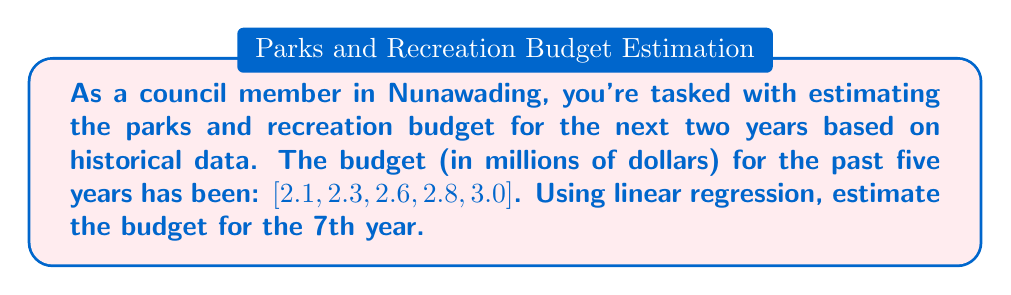Show me your answer to this math problem. To estimate the budget using linear regression, we'll follow these steps:

1. Set up the linear equation: $y = mx + b$, where $y$ is the budget, $x$ is the year, $m$ is the slope, and $b$ is the y-intercept.

2. Calculate the means of $x$ and $y$:
   $\bar{x} = \frac{1+2+3+4+5}{5} = 3$
   $\bar{y} = \frac{2.1+2.3+2.6+2.8+3.0}{5} = 2.56$

3. Calculate the slope $m$:
   $m = \frac{\sum(x_i - \bar{x})(y_i - \bar{y})}{\sum(x_i - \bar{x})^2}$

   $\sum(x_i - \bar{x})(y_i - \bar{y}) = (-2)(-0.46) + (-1)(-0.26) + (0)(0.04) + (1)(0.24) + (2)(0.44) = 1.58$
   $\sum(x_i - \bar{x})^2 = (-2)^2 + (-1)^2 + 0^2 + 1^2 + 2^2 = 10$

   $m = \frac{1.58}{10} = 0.158$

4. Calculate the y-intercept $b$:
   $b = \bar{y} - m\bar{x} = 2.56 - 0.158(3) = 2.086$

5. The linear regression equation is:
   $y = 0.158x + 2.086$

6. To estimate the budget for the 7th year, substitute $x = 7$:
   $y = 0.158(7) + 2.086 = 3.192$

Therefore, the estimated budget for the 7th year is $3.192 million.
Answer: $3.192 million 